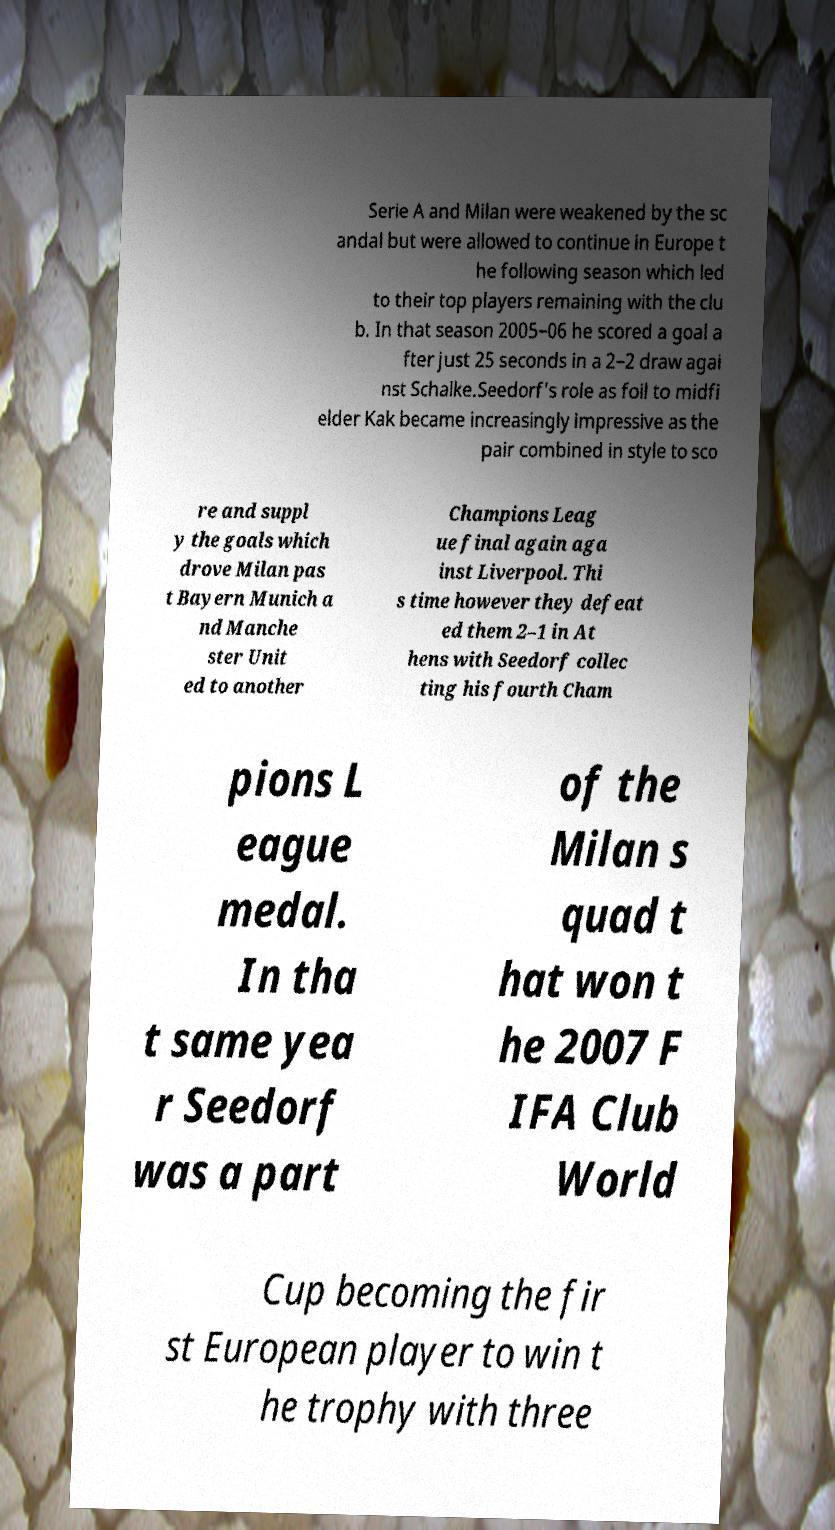There's text embedded in this image that I need extracted. Can you transcribe it verbatim? Serie A and Milan were weakened by the sc andal but were allowed to continue in Europe t he following season which led to their top players remaining with the clu b. In that season 2005–06 he scored a goal a fter just 25 seconds in a 2–2 draw agai nst Schalke.Seedorf's role as foil to midfi elder Kak became increasingly impressive as the pair combined in style to sco re and suppl y the goals which drove Milan pas t Bayern Munich a nd Manche ster Unit ed to another Champions Leag ue final again aga inst Liverpool. Thi s time however they defeat ed them 2–1 in At hens with Seedorf collec ting his fourth Cham pions L eague medal. In tha t same yea r Seedorf was a part of the Milan s quad t hat won t he 2007 F IFA Club World Cup becoming the fir st European player to win t he trophy with three 